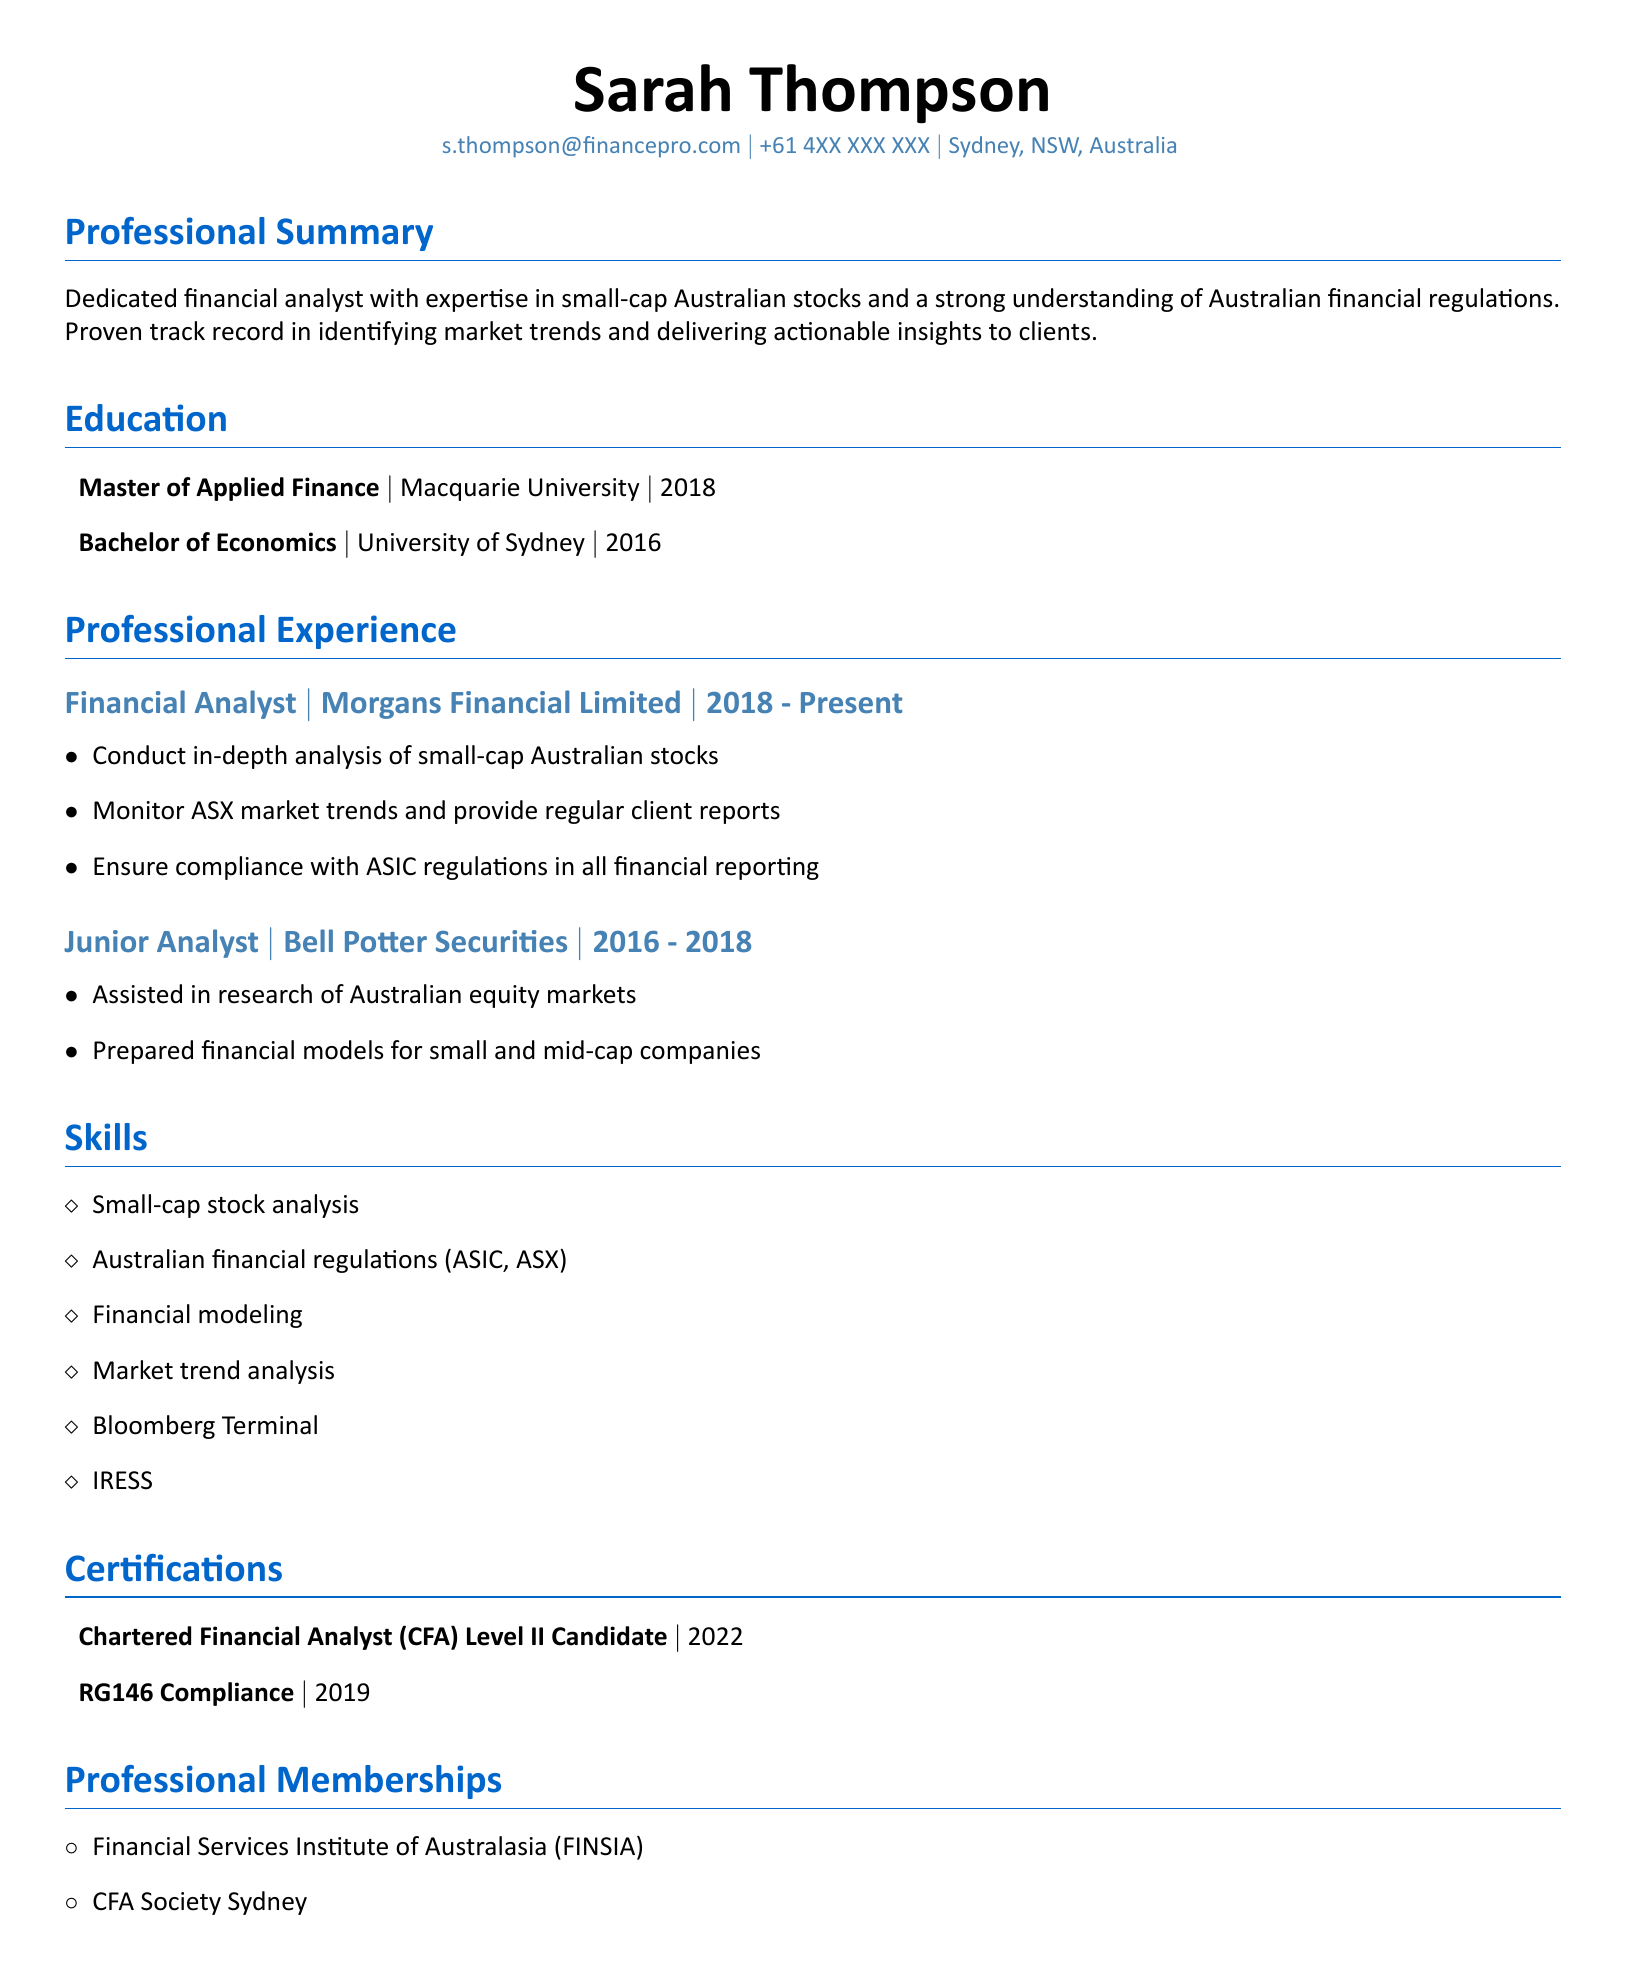What is Sarah Thompson's email address? The document states her email as a part of her personal information.
Answer: s.thompson@financepro.com Which university did Sarah Thompson attend for her Master's degree? The document indicates the institution where she completed her Master's degree.
Answer: Macquarie University In which year did Sarah Thompson obtain her Bachelor of Economics? The Bachelor of Economics degree year is mentioned in the education section of the document.
Answer: 2016 What is the name of the company where Sarah currently works? The professional experience section lists her current employer.
Answer: Morgans Financial Limited How many years did Sarah work as a Junior Analyst? The duration of her employment at Bell Potter Securities is provided in the document, allowing for calculation.
Answer: 2 years What is one of Sarah's areas of expertise? Skills listed in the CV highlight her specific areas of expertise in finance.
Answer: Small-cap stock analysis Which professional membership does Sarah belong to? The document details her professional memberships highlighting her affiliations.
Answer: CFA Society Sydney What certification is Sarah a candidate for? The certifications section indicates her current status regarding certification.
Answer: Chartered Financial Analyst (CFA) Level II Candidate Which financial regulation body does Sarah ensure compliance with? Responsibilities in her professional experience mention compliance with a regulatory body.
Answer: ASIC 